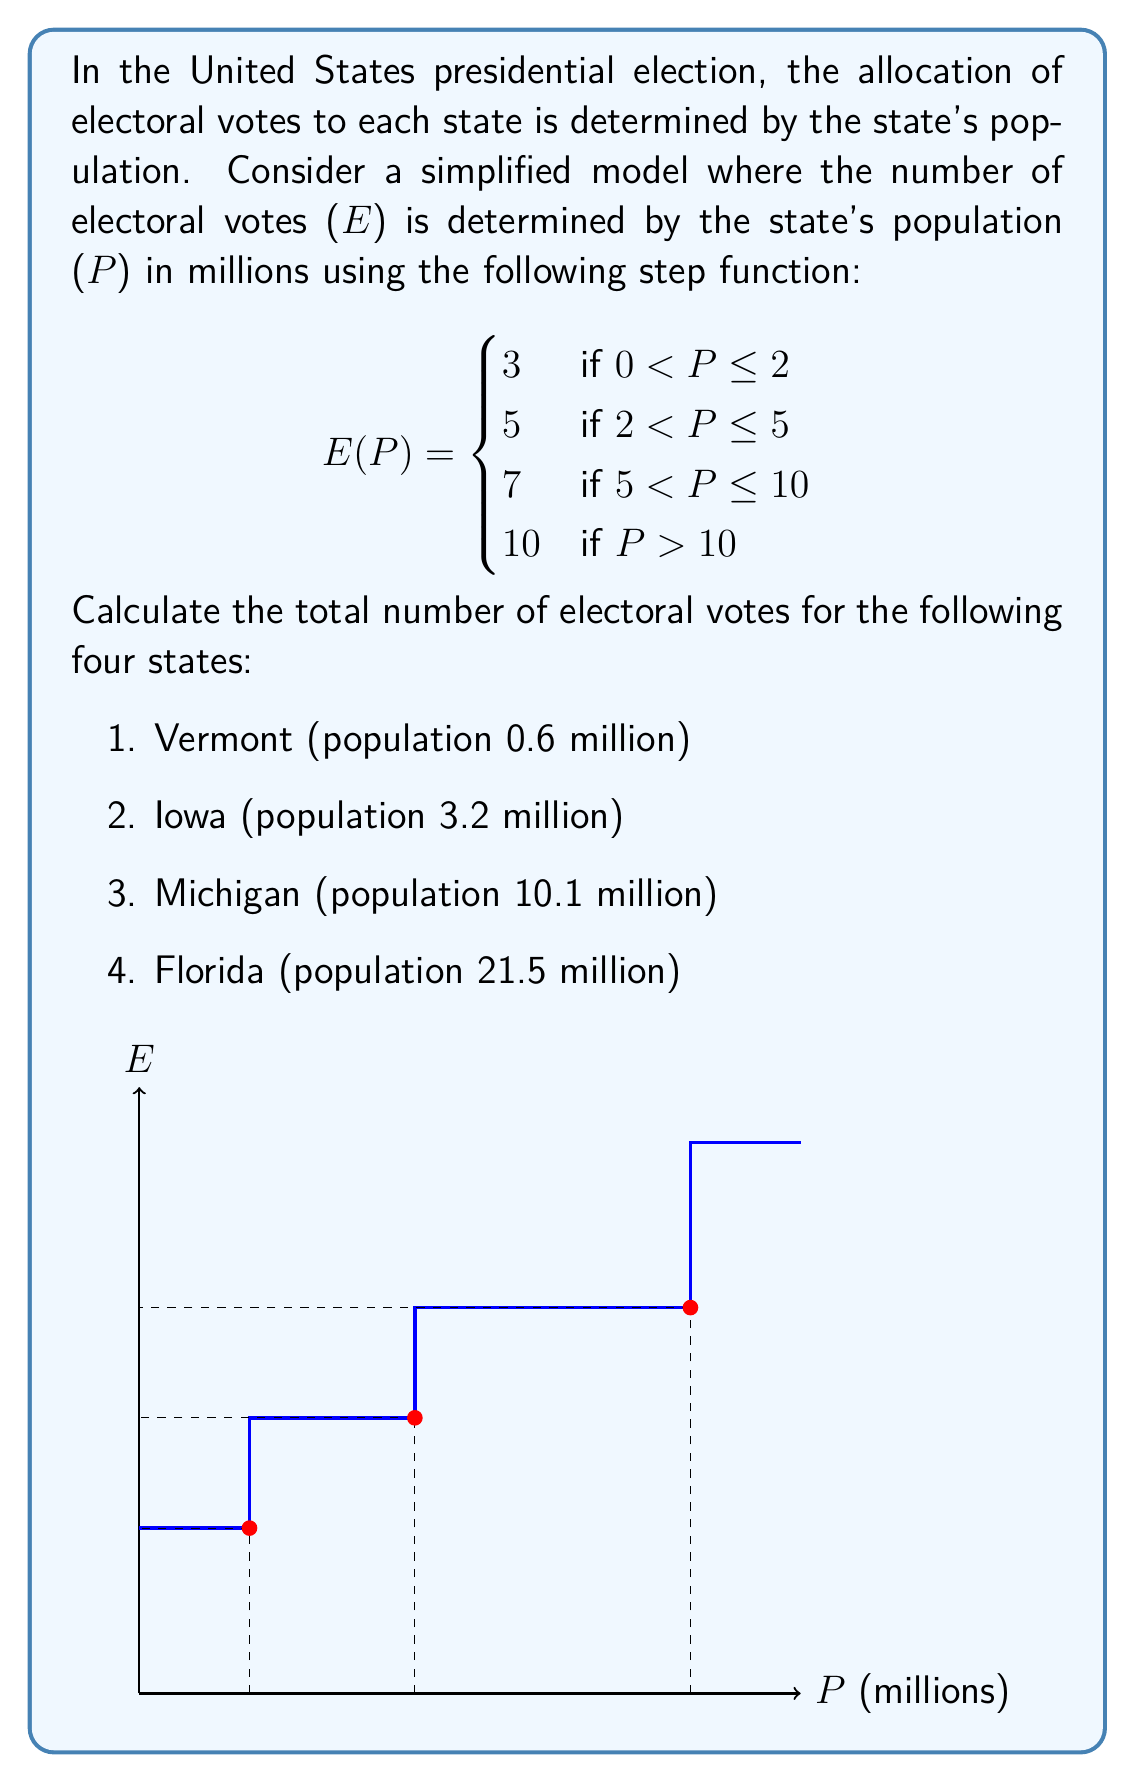Teach me how to tackle this problem. Let's calculate the electoral votes for each state using the given step function:

1. Vermont (population 0.6 million):
   $0 < 0.6 \leq 2$, so $E(0.6) = 3$ electoral votes

2. Iowa (population 3.2 million):
   $2 < 3.2 \leq 5$, so $E(3.2) = 5$ electoral votes

3. Michigan (population 10.1 million):
   $P > 10$, so $E(10.1) = 10$ electoral votes

4. Florida (population 21.5 million):
   $P > 10$, so $E(21.5) = 10$ electoral votes

To find the total number of electoral votes, we sum the individual values:

$$\text{Total Electoral Votes} = 3 + 5 + 10 + 10 = 28$$
Answer: 28 electoral votes 